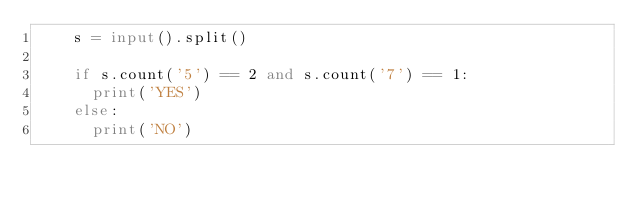Convert code to text. <code><loc_0><loc_0><loc_500><loc_500><_Python_>    s = input().split()
     
    if s.count('5') == 2 and s.count('7') == 1:
      print('YES')
    else:
      print('NO')</code> 